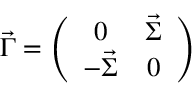Convert formula to latex. <formula><loc_0><loc_0><loc_500><loc_500>\vec { \Gamma } = \left ( \begin{array} { c c } { 0 } & { { \vec { \Sigma } } } \\ { { - \vec { \Sigma } } } & { 0 } \end{array} \right )</formula> 